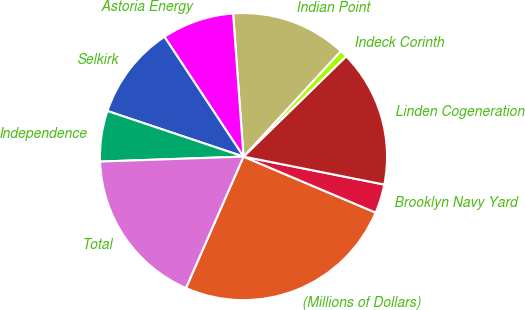Convert chart to OTSL. <chart><loc_0><loc_0><loc_500><loc_500><pie_chart><fcel>(Millions of Dollars)<fcel>Brooklyn Navy Yard<fcel>Linden Cogeneration<fcel>Indeck Corinth<fcel>Indian Point<fcel>Astoria Energy<fcel>Selkirk<fcel>Independence<fcel>Total<nl><fcel>25.19%<fcel>3.26%<fcel>15.44%<fcel>0.83%<fcel>13.01%<fcel>8.13%<fcel>10.57%<fcel>5.7%<fcel>17.88%<nl></chart> 